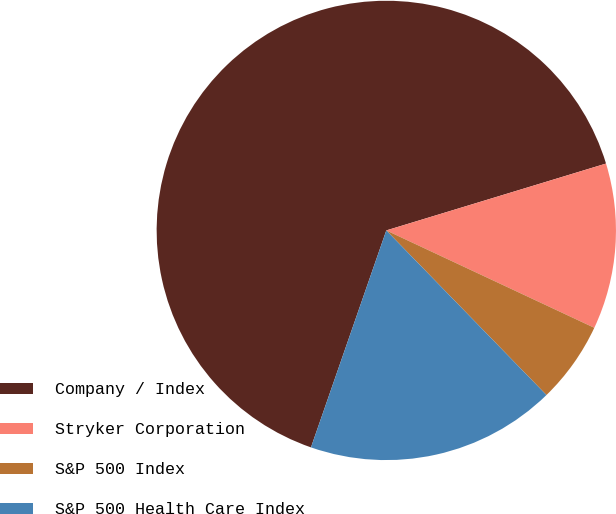Convert chart to OTSL. <chart><loc_0><loc_0><loc_500><loc_500><pie_chart><fcel>Company / Index<fcel>Stryker Corporation<fcel>S&P 500 Index<fcel>S&P 500 Health Care Index<nl><fcel>64.98%<fcel>11.67%<fcel>5.75%<fcel>17.6%<nl></chart> 